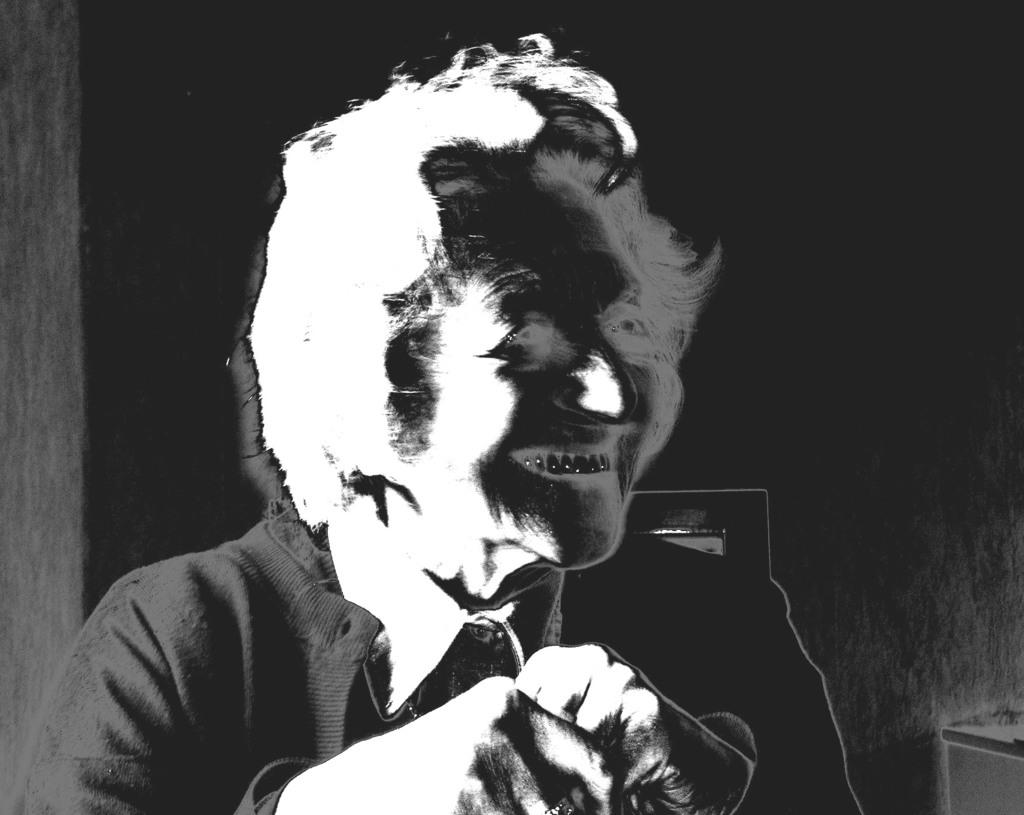Who is the main subject in the image? There is a woman in the image. What is the woman wearing? The woman is wearing a black overcoat. What is the woman's facial expression in the image? The woman is smiling. Can you tell if the image has been altered in any way? Yes, the image has been edited. What type of straw is the woman holding in the image? There is no straw present in the image. Can you see a wren perched on the woman's shoulder in the image? No, there is no wren present in the image. 